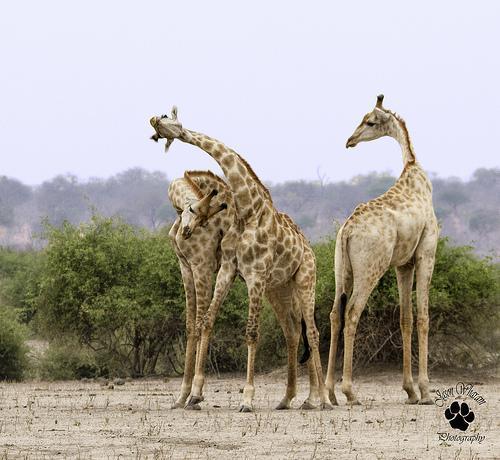How many giraffes are there?
Give a very brief answer. 3. 